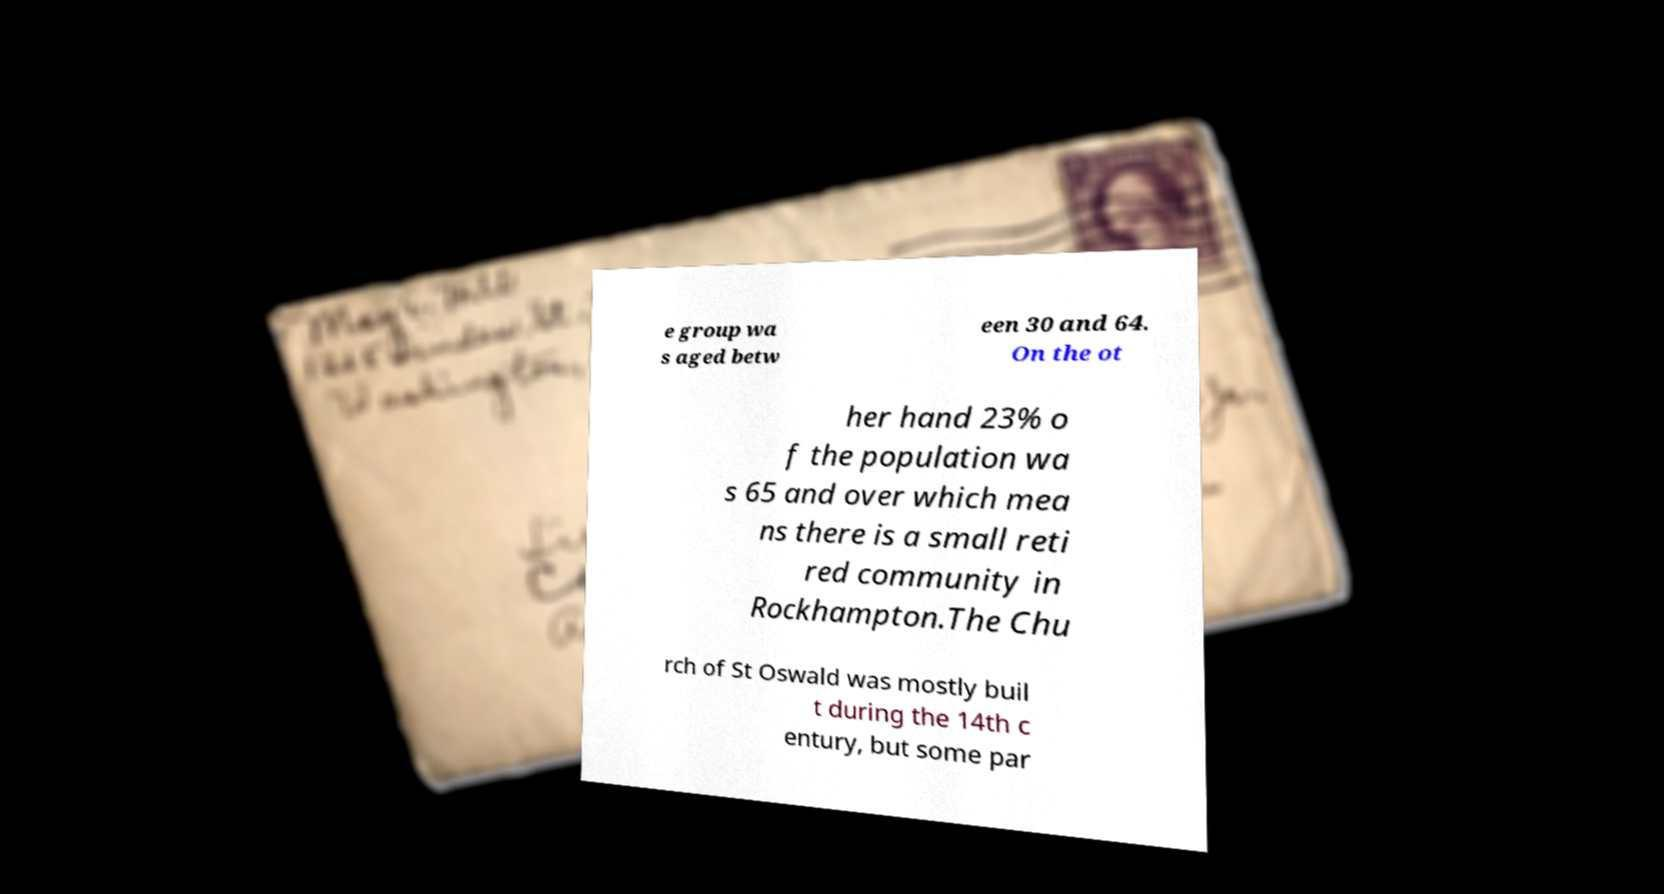What messages or text are displayed in this image? I need them in a readable, typed format. e group wa s aged betw een 30 and 64. On the ot her hand 23% o f the population wa s 65 and over which mea ns there is a small reti red community in Rockhampton.The Chu rch of St Oswald was mostly buil t during the 14th c entury, but some par 